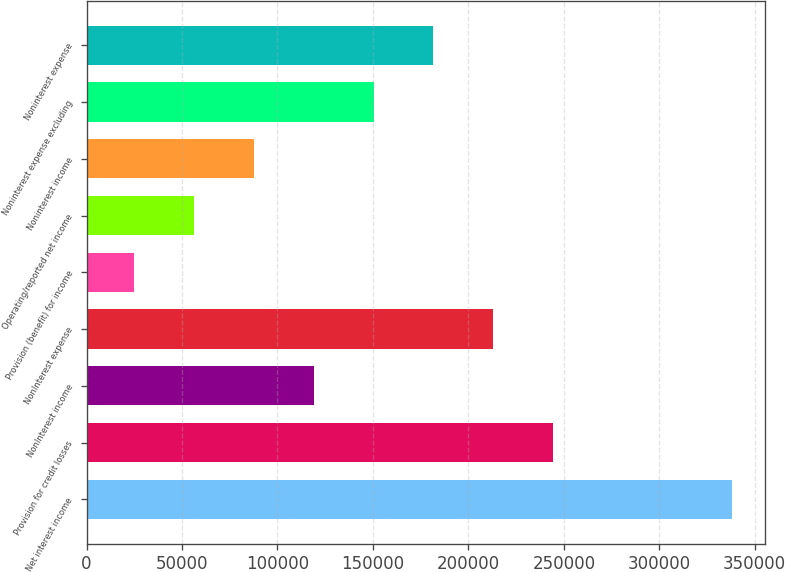<chart> <loc_0><loc_0><loc_500><loc_500><bar_chart><fcel>Net interest income<fcel>Provision for credit losses<fcel>NonInterest income<fcel>NonInterest expense<fcel>Provision (benefit) for income<fcel>Operating/reported net income<fcel>Noninterest income<fcel>Noninterest expense excluding<fcel>Noninterest expense<nl><fcel>338312<fcel>244328<fcel>119017<fcel>213000<fcel>25033<fcel>56360.9<fcel>87688.8<fcel>150345<fcel>181672<nl></chart> 